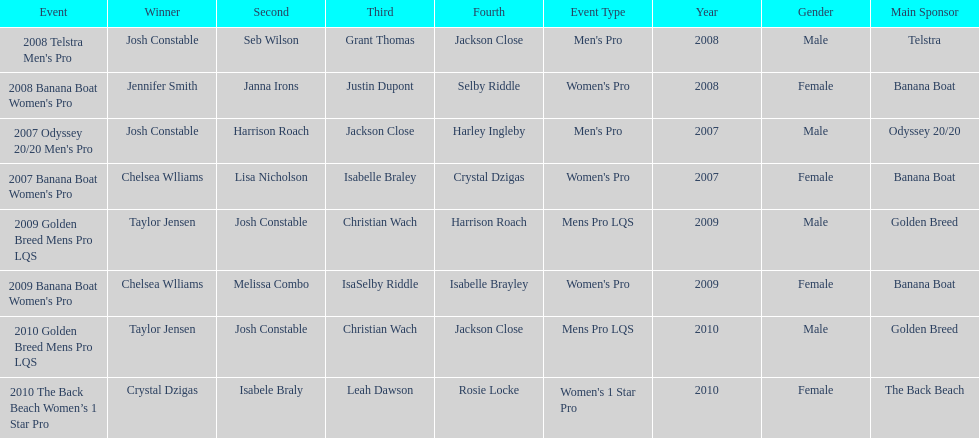In what event did chelsea williams win her first title? 2007 Banana Boat Women's Pro. 